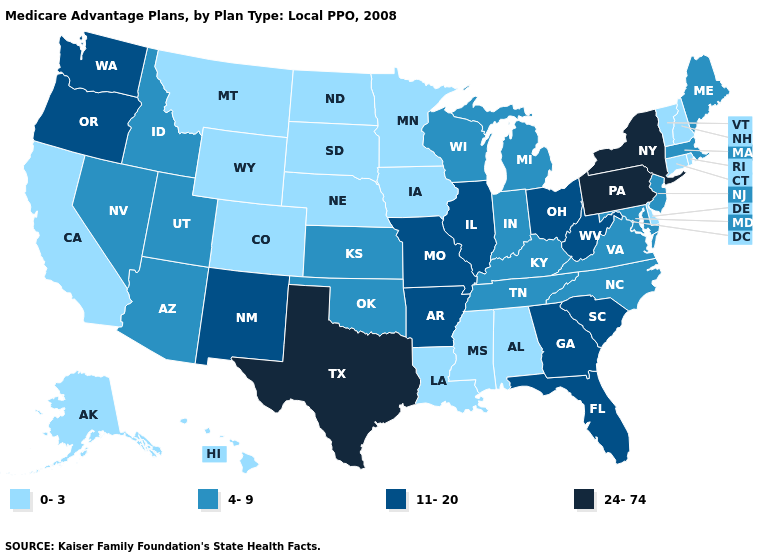Name the states that have a value in the range 11-20?
Be succinct. Arkansas, Florida, Georgia, Illinois, Missouri, New Mexico, Ohio, Oregon, South Carolina, Washington, West Virginia. Name the states that have a value in the range 4-9?
Concise answer only. Arizona, Idaho, Indiana, Kansas, Kentucky, Massachusetts, Maryland, Maine, Michigan, North Carolina, New Jersey, Nevada, Oklahoma, Tennessee, Utah, Virginia, Wisconsin. Name the states that have a value in the range 0-3?
Concise answer only. Alaska, Alabama, California, Colorado, Connecticut, Delaware, Hawaii, Iowa, Louisiana, Minnesota, Mississippi, Montana, North Dakota, Nebraska, New Hampshire, Rhode Island, South Dakota, Vermont, Wyoming. Does the first symbol in the legend represent the smallest category?
Give a very brief answer. Yes. Which states have the lowest value in the Northeast?
Concise answer only. Connecticut, New Hampshire, Rhode Island, Vermont. What is the value of South Carolina?
Give a very brief answer. 11-20. Does Ohio have the highest value in the USA?
Be succinct. No. Does Ohio have the highest value in the MidWest?
Keep it brief. Yes. How many symbols are there in the legend?
Concise answer only. 4. Name the states that have a value in the range 24-74?
Short answer required. New York, Pennsylvania, Texas. Which states have the highest value in the USA?
Write a very short answer. New York, Pennsylvania, Texas. Among the states that border New Hampshire , does Vermont have the lowest value?
Write a very short answer. Yes. Does Rhode Island have the same value as Hawaii?
Quick response, please. Yes. What is the highest value in the Northeast ?
Short answer required. 24-74. 